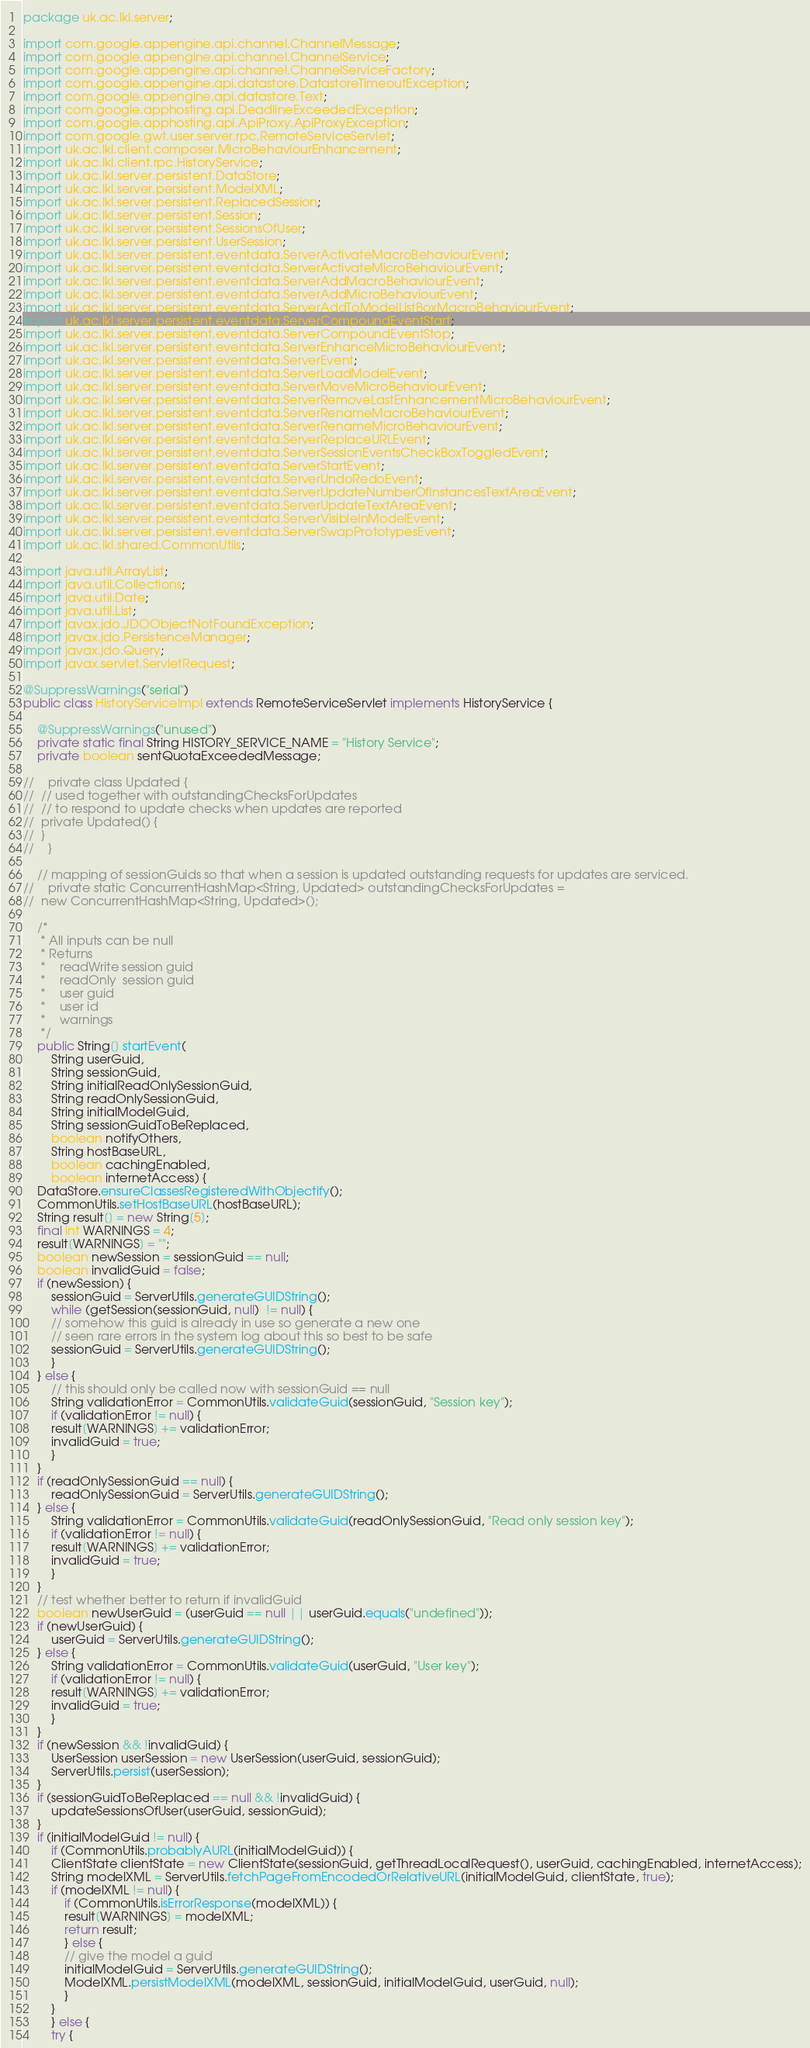Convert code to text. <code><loc_0><loc_0><loc_500><loc_500><_Java_>package uk.ac.lkl.server;

import com.google.appengine.api.channel.ChannelMessage;
import com.google.appengine.api.channel.ChannelService;
import com.google.appengine.api.channel.ChannelServiceFactory;
import com.google.appengine.api.datastore.DatastoreTimeoutException;
import com.google.appengine.api.datastore.Text;
import com.google.apphosting.api.DeadlineExceededException;
import com.google.apphosting.api.ApiProxy.ApiProxyException;
import com.google.gwt.user.server.rpc.RemoteServiceServlet;
import uk.ac.lkl.client.composer.MicroBehaviourEnhancement;
import uk.ac.lkl.client.rpc.HistoryService;
import uk.ac.lkl.server.persistent.DataStore;
import uk.ac.lkl.server.persistent.ModelXML;
import uk.ac.lkl.server.persistent.ReplacedSession;
import uk.ac.lkl.server.persistent.Session;
import uk.ac.lkl.server.persistent.SessionsOfUser;
import uk.ac.lkl.server.persistent.UserSession;
import uk.ac.lkl.server.persistent.eventdata.ServerActivateMacroBehaviourEvent;
import uk.ac.lkl.server.persistent.eventdata.ServerActivateMicroBehaviourEvent;
import uk.ac.lkl.server.persistent.eventdata.ServerAddMacroBehaviourEvent;
import uk.ac.lkl.server.persistent.eventdata.ServerAddMicroBehaviourEvent;
import uk.ac.lkl.server.persistent.eventdata.ServerAddToModelListBoxMacroBehaviourEvent;
import uk.ac.lkl.server.persistent.eventdata.ServerCompoundEventStart;
import uk.ac.lkl.server.persistent.eventdata.ServerCompoundEventStop;
import uk.ac.lkl.server.persistent.eventdata.ServerEnhanceMicroBehaviourEvent;
import uk.ac.lkl.server.persistent.eventdata.ServerEvent;
import uk.ac.lkl.server.persistent.eventdata.ServerLoadModelEvent;
import uk.ac.lkl.server.persistent.eventdata.ServerMoveMicroBehaviourEvent;
import uk.ac.lkl.server.persistent.eventdata.ServerRemoveLastEnhancementMicroBehaviourEvent;
import uk.ac.lkl.server.persistent.eventdata.ServerRenameMacroBehaviourEvent;
import uk.ac.lkl.server.persistent.eventdata.ServerRenameMicroBehaviourEvent;
import uk.ac.lkl.server.persistent.eventdata.ServerReplaceURLEvent;
import uk.ac.lkl.server.persistent.eventdata.ServerSessionEventsCheckBoxToggledEvent;
import uk.ac.lkl.server.persistent.eventdata.ServerStartEvent;
import uk.ac.lkl.server.persistent.eventdata.ServerUndoRedoEvent;
import uk.ac.lkl.server.persistent.eventdata.ServerUpdateNumberOfInstancesTextAreaEvent;
import uk.ac.lkl.server.persistent.eventdata.ServerUpdateTextAreaEvent;
import uk.ac.lkl.server.persistent.eventdata.ServerVisibleInModelEvent;
import uk.ac.lkl.server.persistent.eventdata.ServerSwapPrototypesEvent;
import uk.ac.lkl.shared.CommonUtils;

import java.util.ArrayList;
import java.util.Collections;
import java.util.Date;
import java.util.List;
import javax.jdo.JDOObjectNotFoundException;
import javax.jdo.PersistenceManager;
import javax.jdo.Query;
import javax.servlet.ServletRequest;

@SuppressWarnings("serial")
public class HistoryServiceImpl extends RemoteServiceServlet implements HistoryService {

    @SuppressWarnings("unused")
    private static final String HISTORY_SERVICE_NAME = "History Service";
    private boolean sentQuotaExceededMessage;

//    private class Updated {
//	// used together with outstandingChecksForUpdates
//	// to respond to update checks when updates are reported
//	private Updated() {    
//	}
//    }
    
    // mapping of sessionGuids so that when a session is updated outstanding requests for updates are serviced.
//    private static ConcurrentHashMap<String, Updated> outstandingChecksForUpdates =
//	new ConcurrentHashMap<String, Updated>();    
    
    /* 
     * All inputs can be null
     * Returns
     *    readWrite session guid
     *    readOnly  session guid
     *    user guid
     *    user id
     *    warnings
     */
    public String[] startEvent(
	    String userGuid,
	    String sessionGuid, 
	    String initialReadOnlySessionGuid, 
	    String readOnlySessionGuid, 
	    String initialModelGuid,
	    String sessionGuidToBeReplaced,
	    boolean notifyOthers,
	    String hostBaseURL,
	    boolean cachingEnabled,
	    boolean internetAccess) {
	DataStore.ensureClassesRegisteredWithObjectify();
	CommonUtils.setHostBaseURL(hostBaseURL);
	String result[] = new String[5];
	final int WARNINGS = 4;
	result[WARNINGS] = ""; 
	boolean newSession = sessionGuid == null;
	boolean invalidGuid = false;
	if (newSession) {
	    sessionGuid = ServerUtils.generateGUIDString();
	    while (getSession(sessionGuid, null)  != null) {
		// somehow this guid is already in use so generate a new one
		// seen rare errors in the system log about this so best to be safe
		sessionGuid = ServerUtils.generateGUIDString();
	    }
	} else {
	    // this should only be called now with sessionGuid == null
	    String validationError = CommonUtils.validateGuid(sessionGuid, "Session key");
	    if (validationError != null) {
		result[WARNINGS] += validationError;
		invalidGuid = true;
	    }
	}
	if (readOnlySessionGuid == null) {
	    readOnlySessionGuid = ServerUtils.generateGUIDString();
	} else {
	    String validationError = CommonUtils.validateGuid(readOnlySessionGuid, "Read only session key");
	    if (validationError != null) {
		result[WARNINGS] += validationError;
		invalidGuid = true;
	    }
	}
	// test whether better to return if invalidGuid 
	boolean newUserGuid = (userGuid == null || userGuid.equals("undefined"));
	if (newUserGuid) {
	    userGuid = ServerUtils.generateGUIDString();
	} else {
	    String validationError = CommonUtils.validateGuid(userGuid, "User key");
	    if (validationError != null) {
		result[WARNINGS] += validationError;
		invalidGuid = true;
	    }
	}
	if (newSession && !invalidGuid) {
	    UserSession userSession = new UserSession(userGuid, sessionGuid);
	    ServerUtils.persist(userSession);
	}
	if (sessionGuidToBeReplaced == null && !invalidGuid) {
	    updateSessionsOfUser(userGuid, sessionGuid);
	}
	if (initialModelGuid != null) {
	    if (CommonUtils.probablyAURL(initialModelGuid)) {
		ClientState clientState = new ClientState(sessionGuid, getThreadLocalRequest(), userGuid, cachingEnabled, internetAccess);
		String modelXML = ServerUtils.fetchPageFromEncodedOrRelativeURL(initialModelGuid, clientState, true);
		if (modelXML != null) {
		    if (CommonUtils.isErrorResponse(modelXML)) {
			result[WARNINGS] = modelXML;
			return result;
		    } else {
			// give the model a guid
			initialModelGuid = ServerUtils.generateGUIDString();
			ModelXML.persistModelXML(modelXML, sessionGuid, initialModelGuid, userGuid, null);
		    }
		}
	    } else {
		try {</code> 